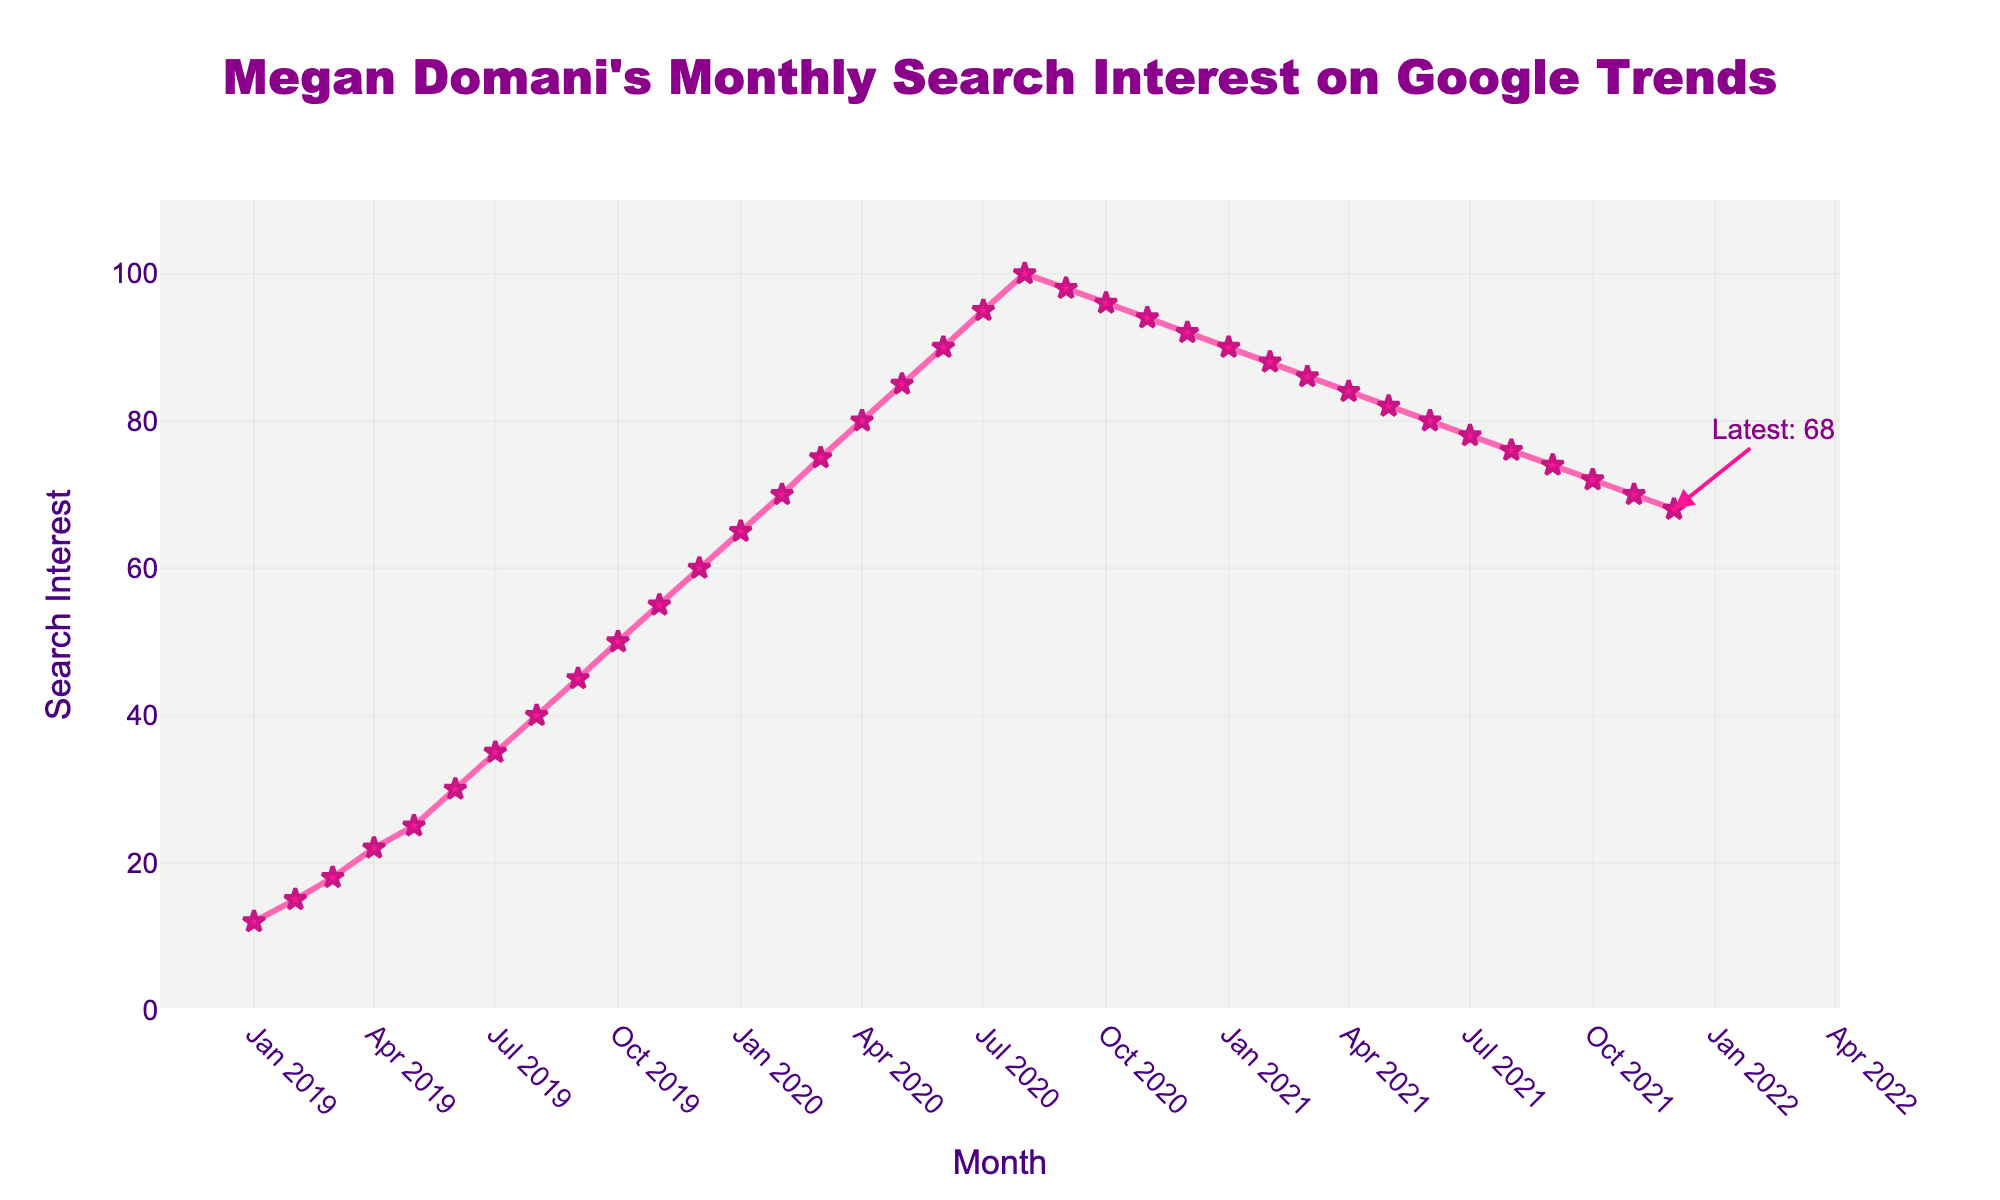What's the highest search interest value and when did it occur? The highest search interest value on the plot is 100, which occurred in August 2020. The peak is visually identifiable from the line reaching its highest point.
Answer: 100 in August 2020 From January 2019 to December 2019, by how much did the search interest increase? In January 2019, the search interest was 12 and in December 2019, it was 60. The increase is calculated as 60 - 12 = 48.
Answer: 48 What is the overall trend in search interest from January 2020 to December 2021? The search interest initially peaks at 100 in August 2020, then generally declines until December 2021. This is evident from the decrease in the height of the line after August 2020.
Answer: Increasing then decreasing How many months did the search interest stay above 90? From the plot, the search interest stayed above 90 from June 2020 to February 2021, totaling 9 months. This is discerned by counting the months as shown on the x-axis where the line is above the 90 mark on the y-axis.
Answer: 9 months Compare the search interest value in May 2019 and May 2020. By how much did it change? In May 2019, the search interest was 25, and in May 2020, it was 85. The change is calculated as 85 - 25 = 60.
Answer: 60 What month experienced the sharpest decline in search interest? The sharpest decline is visible from August 2020 to September 2020, where the search interest drops from 100 to 98. Although the decline is small compared to the gradual decrease later, it’s the steepest drop in a one-month period on the chart.
Answer: September 2020 What's the search interest value in December 2021, and how does it compare with January 2020? The search interest in December 2021 is 68, while in January 2020 it was 65. The difference is 68 - 65 = 3, indicating a slight increase.
Answer: 68; 3 higher than January 2020 On average, what was the monthly search interest in 2020? To calculate the average monthly search interest for 2020, sum up all monthly values: (65 + 70 + 75 + 80 + 85 + 90 + 95 + 100 + 98 + 96 + 94 + 92) = 1030. Divide by 12 (the number of months), the average is 1030 / 12 ≈ 85.83.
Answer: 85.83 